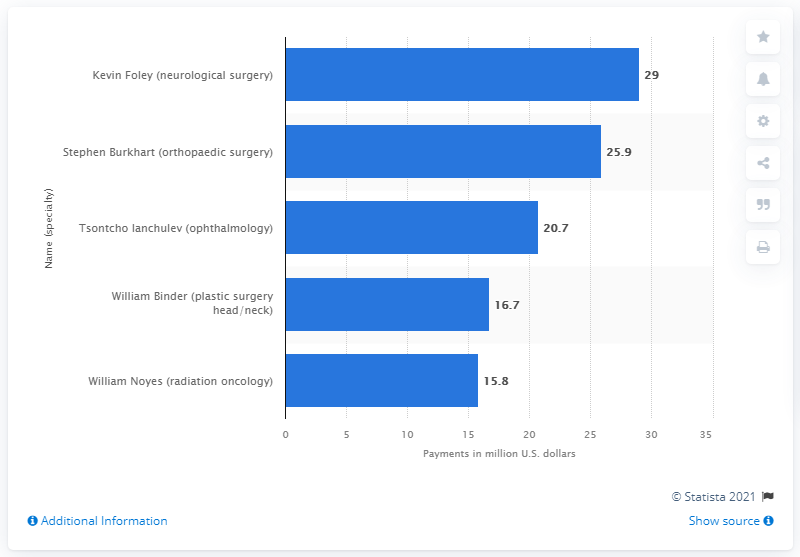Draw attention to some important aspects in this diagram. Kevin Foley was paid a total of $29 million in the United States in 2018. The average of payments that are higher than 22 million U.S dollars is 27.45. William Binder, a plastic surgeon specializing in head and neck procedures, has accrued a net worth of 16.7 million U.S dollars. 